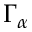<formula> <loc_0><loc_0><loc_500><loc_500>\Gamma _ { \alpha }</formula> 